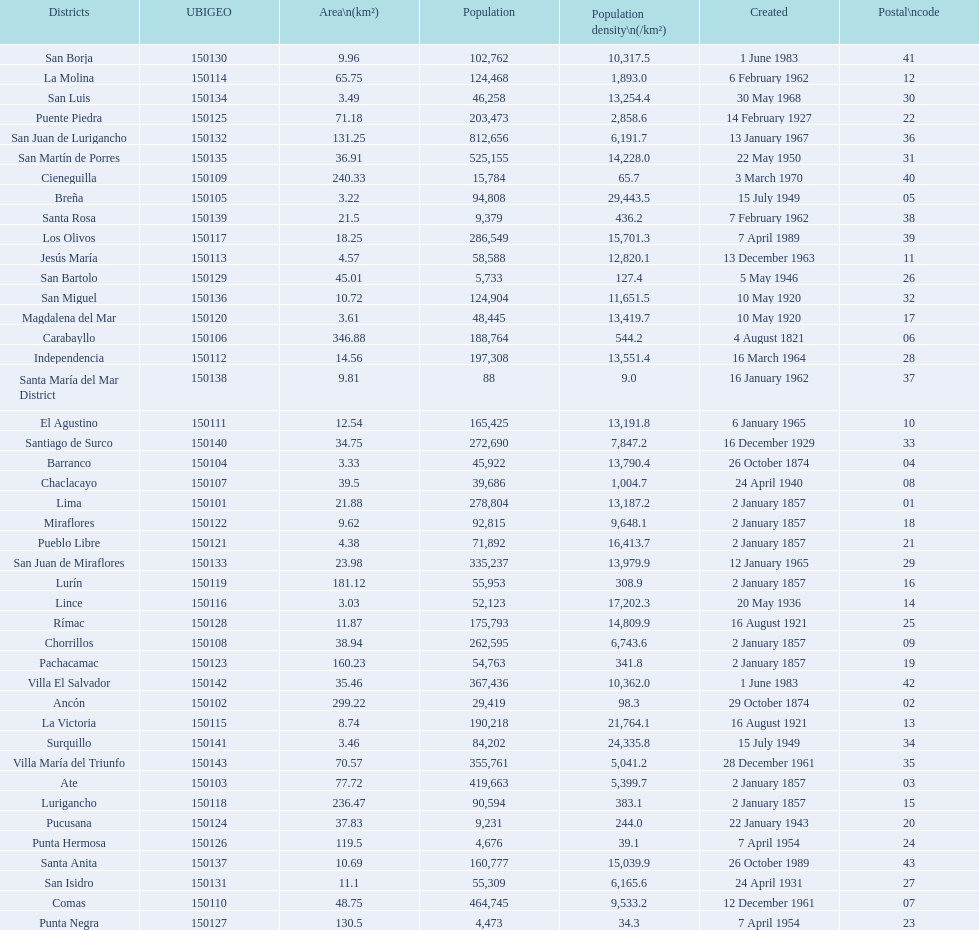Which district in this city has the greatest population? San Juan de Lurigancho. 